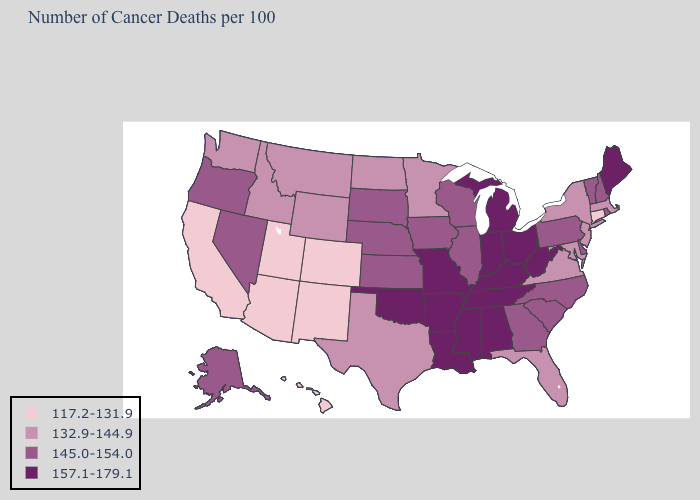What is the lowest value in states that border Oregon?
Keep it brief. 117.2-131.9. What is the lowest value in states that border Washington?
Write a very short answer. 132.9-144.9. What is the value of California?
Write a very short answer. 117.2-131.9. Name the states that have a value in the range 117.2-131.9?
Write a very short answer. Arizona, California, Colorado, Connecticut, Hawaii, New Mexico, Utah. What is the value of Maine?
Concise answer only. 157.1-179.1. Which states hav the highest value in the South?
Concise answer only. Alabama, Arkansas, Kentucky, Louisiana, Mississippi, Oklahoma, Tennessee, West Virginia. Among the states that border Michigan , does Wisconsin have the lowest value?
Concise answer only. Yes. What is the value of New Jersey?
Quick response, please. 132.9-144.9. What is the value of New Mexico?
Write a very short answer. 117.2-131.9. Name the states that have a value in the range 117.2-131.9?
Write a very short answer. Arizona, California, Colorado, Connecticut, Hawaii, New Mexico, Utah. What is the value of Iowa?
Be succinct. 145.0-154.0. How many symbols are there in the legend?
Give a very brief answer. 4. What is the value of Alaska?
Short answer required. 145.0-154.0. What is the value of Alabama?
Quick response, please. 157.1-179.1. Name the states that have a value in the range 145.0-154.0?
Concise answer only. Alaska, Delaware, Georgia, Illinois, Iowa, Kansas, Nebraska, Nevada, New Hampshire, North Carolina, Oregon, Pennsylvania, Rhode Island, South Carolina, South Dakota, Vermont, Wisconsin. 